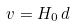<formula> <loc_0><loc_0><loc_500><loc_500>v = H _ { 0 } \, d</formula> 